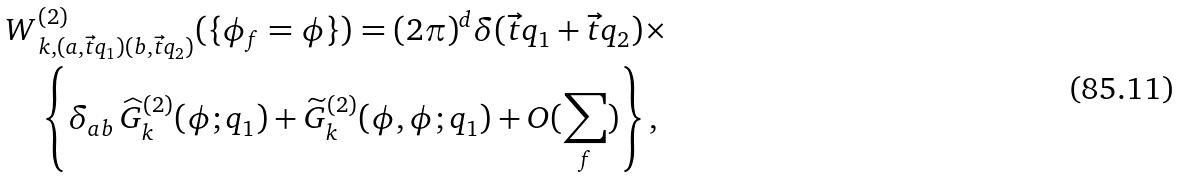<formula> <loc_0><loc_0><loc_500><loc_500>W & _ { k , ( a , \vec { t } q _ { 1 } ) ( b , \vec { t } q _ { 2 } ) } ^ { ( 2 ) } ( \{ \phi _ { f } = \phi \} ) = ( 2 \pi ) ^ { d } \delta ( \vec { t } q _ { 1 } + \vec { t } q _ { 2 } ) \times \\ & \left \{ \delta _ { a b } \, \widehat { G } _ { k } ^ { ( 2 ) } ( \phi ; q _ { 1 } ) + \widetilde { G } _ { k } ^ { ( 2 ) } ( \phi , \phi ; q _ { 1 } ) + O ( \sum _ { f } ) \right \} ,</formula> 